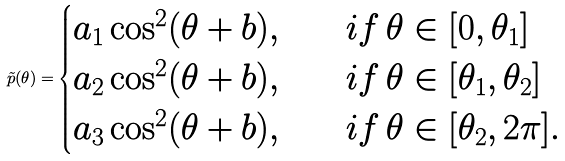<formula> <loc_0><loc_0><loc_500><loc_500>\tilde { p } ( \theta ) = \begin{cases} a _ { 1 } \cos ^ { 2 } ( \theta + b ) , \quad & i f \, \theta \in [ 0 , \theta _ { 1 } ] \\ a _ { 2 } \cos ^ { 2 } ( \theta + b ) , \quad & i f \, \theta \in [ \theta _ { 1 } , \theta _ { 2 } ] \\ a _ { 3 } \cos ^ { 2 } ( \theta + b ) , \quad & i f \, \theta \in [ \theta _ { 2 } , 2 \pi ] . \end{cases}</formula> 